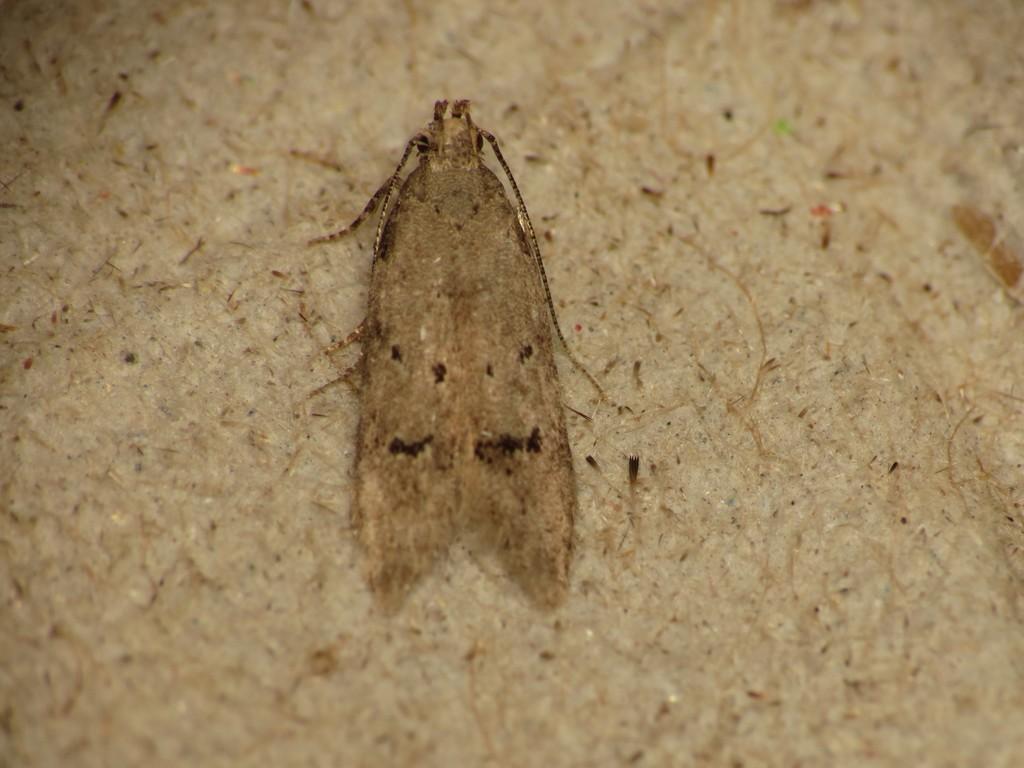How would you summarize this image in a sentence or two? In this picture there is an insect which is in the center. 